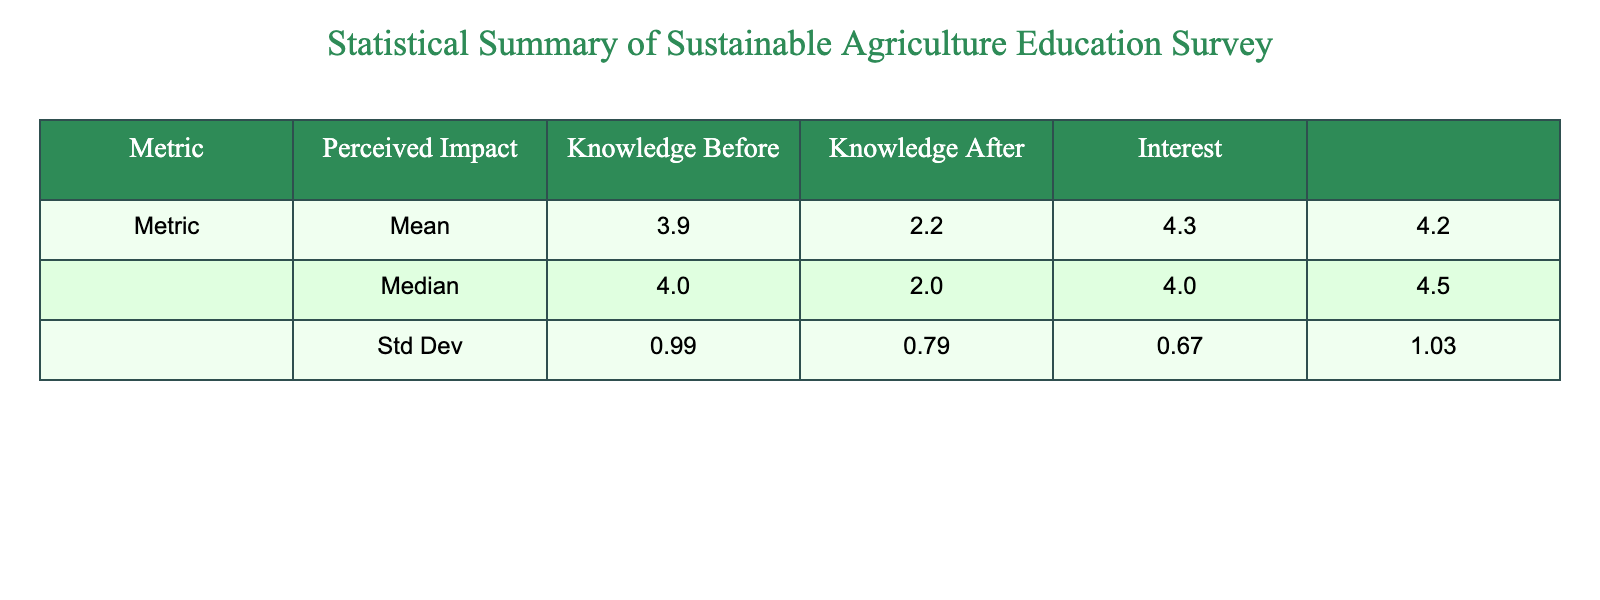What is the mean perceived impact effectiveness score? To find the mean perceived impact effectiveness score, we look at the 'mean' row under the 'Perceived Impact' column. The value is 4.0.
Answer: 4.0 What is the median knowledge before education? The median value for knowledge before education is found in the 'median' row under 'Knowledge Before' column. The value is 3.0.
Answer: 3.0 Is the standard deviation of perceived impact effectiveness greater than that of knowledge after education? The standard deviation for perceived impact effectiveness is 0.71 and for knowledge after education it is 0.74. Since 0.71 is less than 0.74, the statement is false.
Answer: No What is the difference between the mean scores for knowledge before and knowledge after education? The mean score for knowledge before education is 2.9 and for knowledge after is 4.1. To find the difference, we subtract the mean of knowledge before from the mean of knowledge after: 4.1 - 2.9 = 1.2.
Answer: 1.2 What is the highest perceived impact effectiveness score reported? By checking the individual scores in the 'Perceived Impact' column, the highest score is 5.
Answer: 5 What percentage of students reported a perceived impact effectiveness score of 4 or higher? There are 10 students in total. The scores of 4 or higher are found in Alice, Carol, David, Frank, Isaac, and Jack, totaling 6 students. To find the percentage, we calculate (6/10) * 100 = 60%.
Answer: 60% What is the average interest in sustainable agriculture compared to the average perceived impact effectiveness? The average interest in sustainable agriculture is 4.1 and perceived impact effectiveness is 4.0. Since 4.1 is greater than 4.0, it shows higher interest in sustainable agriculture compared to perceived impact effectiveness.
Answer: Higher interest If a new student were to enter the program, what is the likelihood they would have a knowledge after education score of at least 4, based on the average knowledge after education score? The average score for knowledge after education is 4.1, which suggests that more students are likely to score 4 or higher rather than below. Therefore, it indicates a high likelihood.
Answer: High likelihood How many students had an interest in sustainable agriculture score of 5? By reviewing the 'Interest' column, we see that Alice, Carol, Frank, and Isaac scored 5 for interest, totaling 4 students.
Answer: 4 